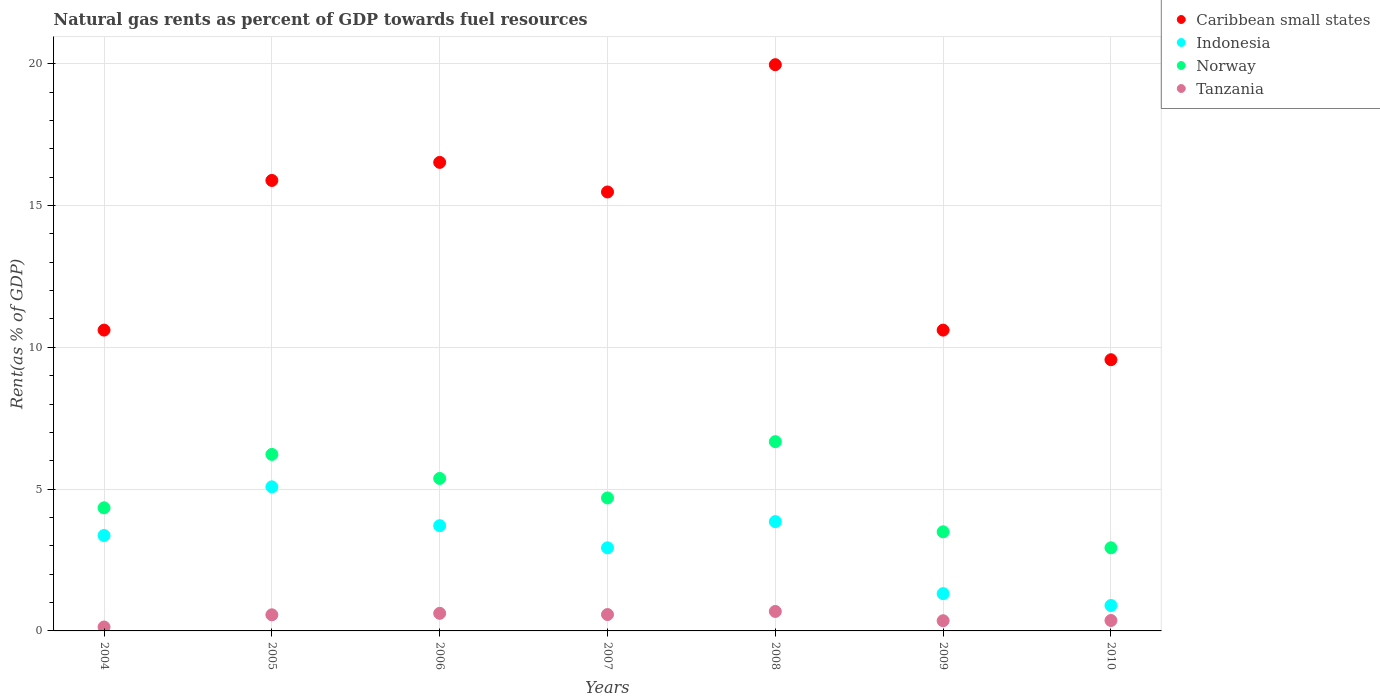How many different coloured dotlines are there?
Ensure brevity in your answer.  4. What is the matural gas rent in Tanzania in 2006?
Provide a short and direct response. 0.62. Across all years, what is the maximum matural gas rent in Caribbean small states?
Provide a succinct answer. 19.97. Across all years, what is the minimum matural gas rent in Caribbean small states?
Your response must be concise. 9.56. What is the total matural gas rent in Norway in the graph?
Make the answer very short. 33.73. What is the difference between the matural gas rent in Indonesia in 2006 and that in 2009?
Your answer should be compact. 2.4. What is the difference between the matural gas rent in Tanzania in 2006 and the matural gas rent in Norway in 2005?
Give a very brief answer. -5.6. What is the average matural gas rent in Indonesia per year?
Offer a very short reply. 3.02. In the year 2008, what is the difference between the matural gas rent in Caribbean small states and matural gas rent in Tanzania?
Ensure brevity in your answer.  19.28. What is the ratio of the matural gas rent in Tanzania in 2006 to that in 2007?
Your response must be concise. 1.07. Is the matural gas rent in Caribbean small states in 2004 less than that in 2006?
Your answer should be very brief. Yes. What is the difference between the highest and the second highest matural gas rent in Indonesia?
Keep it short and to the point. 1.23. What is the difference between the highest and the lowest matural gas rent in Norway?
Your answer should be compact. 3.74. In how many years, is the matural gas rent in Caribbean small states greater than the average matural gas rent in Caribbean small states taken over all years?
Make the answer very short. 4. Is it the case that in every year, the sum of the matural gas rent in Norway and matural gas rent in Caribbean small states  is greater than the sum of matural gas rent in Indonesia and matural gas rent in Tanzania?
Keep it short and to the point. Yes. Is the matural gas rent in Norway strictly less than the matural gas rent in Caribbean small states over the years?
Provide a short and direct response. Yes. How many dotlines are there?
Your answer should be compact. 4. How many years are there in the graph?
Provide a short and direct response. 7. Does the graph contain any zero values?
Offer a terse response. No. Where does the legend appear in the graph?
Make the answer very short. Top right. What is the title of the graph?
Keep it short and to the point. Natural gas rents as percent of GDP towards fuel resources. Does "Vanuatu" appear as one of the legend labels in the graph?
Provide a succinct answer. No. What is the label or title of the X-axis?
Your response must be concise. Years. What is the label or title of the Y-axis?
Your response must be concise. Rent(as % of GDP). What is the Rent(as % of GDP) in Caribbean small states in 2004?
Give a very brief answer. 10.61. What is the Rent(as % of GDP) of Indonesia in 2004?
Provide a short and direct response. 3.36. What is the Rent(as % of GDP) of Norway in 2004?
Give a very brief answer. 4.34. What is the Rent(as % of GDP) in Tanzania in 2004?
Your answer should be very brief. 0.14. What is the Rent(as % of GDP) of Caribbean small states in 2005?
Offer a terse response. 15.89. What is the Rent(as % of GDP) of Indonesia in 2005?
Provide a succinct answer. 5.08. What is the Rent(as % of GDP) of Norway in 2005?
Your answer should be very brief. 6.22. What is the Rent(as % of GDP) in Tanzania in 2005?
Provide a short and direct response. 0.57. What is the Rent(as % of GDP) of Caribbean small states in 2006?
Your response must be concise. 16.52. What is the Rent(as % of GDP) in Indonesia in 2006?
Offer a terse response. 3.71. What is the Rent(as % of GDP) of Norway in 2006?
Your answer should be compact. 5.38. What is the Rent(as % of GDP) of Tanzania in 2006?
Give a very brief answer. 0.62. What is the Rent(as % of GDP) in Caribbean small states in 2007?
Your answer should be very brief. 15.48. What is the Rent(as % of GDP) in Indonesia in 2007?
Your answer should be compact. 2.93. What is the Rent(as % of GDP) of Norway in 2007?
Ensure brevity in your answer.  4.69. What is the Rent(as % of GDP) in Tanzania in 2007?
Keep it short and to the point. 0.58. What is the Rent(as % of GDP) in Caribbean small states in 2008?
Your answer should be compact. 19.97. What is the Rent(as % of GDP) in Indonesia in 2008?
Offer a very short reply. 3.85. What is the Rent(as % of GDP) in Norway in 2008?
Your answer should be compact. 6.67. What is the Rent(as % of GDP) of Tanzania in 2008?
Your response must be concise. 0.69. What is the Rent(as % of GDP) in Caribbean small states in 2009?
Provide a short and direct response. 10.61. What is the Rent(as % of GDP) of Indonesia in 2009?
Your answer should be very brief. 1.32. What is the Rent(as % of GDP) in Norway in 2009?
Your response must be concise. 3.49. What is the Rent(as % of GDP) of Tanzania in 2009?
Make the answer very short. 0.36. What is the Rent(as % of GDP) of Caribbean small states in 2010?
Offer a very short reply. 9.56. What is the Rent(as % of GDP) in Indonesia in 2010?
Your answer should be compact. 0.9. What is the Rent(as % of GDP) in Norway in 2010?
Your response must be concise. 2.93. What is the Rent(as % of GDP) in Tanzania in 2010?
Keep it short and to the point. 0.37. Across all years, what is the maximum Rent(as % of GDP) of Caribbean small states?
Offer a terse response. 19.97. Across all years, what is the maximum Rent(as % of GDP) of Indonesia?
Ensure brevity in your answer.  5.08. Across all years, what is the maximum Rent(as % of GDP) of Norway?
Keep it short and to the point. 6.67. Across all years, what is the maximum Rent(as % of GDP) in Tanzania?
Provide a succinct answer. 0.69. Across all years, what is the minimum Rent(as % of GDP) of Caribbean small states?
Your answer should be very brief. 9.56. Across all years, what is the minimum Rent(as % of GDP) of Indonesia?
Provide a short and direct response. 0.9. Across all years, what is the minimum Rent(as % of GDP) in Norway?
Your answer should be very brief. 2.93. Across all years, what is the minimum Rent(as % of GDP) of Tanzania?
Provide a short and direct response. 0.14. What is the total Rent(as % of GDP) of Caribbean small states in the graph?
Offer a very short reply. 98.63. What is the total Rent(as % of GDP) in Indonesia in the graph?
Your answer should be very brief. 21.15. What is the total Rent(as % of GDP) in Norway in the graph?
Your answer should be compact. 33.73. What is the total Rent(as % of GDP) of Tanzania in the graph?
Your response must be concise. 3.32. What is the difference between the Rent(as % of GDP) in Caribbean small states in 2004 and that in 2005?
Keep it short and to the point. -5.28. What is the difference between the Rent(as % of GDP) in Indonesia in 2004 and that in 2005?
Make the answer very short. -1.72. What is the difference between the Rent(as % of GDP) of Norway in 2004 and that in 2005?
Your answer should be compact. -1.88. What is the difference between the Rent(as % of GDP) of Tanzania in 2004 and that in 2005?
Make the answer very short. -0.43. What is the difference between the Rent(as % of GDP) in Caribbean small states in 2004 and that in 2006?
Your answer should be very brief. -5.91. What is the difference between the Rent(as % of GDP) in Indonesia in 2004 and that in 2006?
Your response must be concise. -0.35. What is the difference between the Rent(as % of GDP) in Norway in 2004 and that in 2006?
Make the answer very short. -1.04. What is the difference between the Rent(as % of GDP) of Tanzania in 2004 and that in 2006?
Ensure brevity in your answer.  -0.48. What is the difference between the Rent(as % of GDP) of Caribbean small states in 2004 and that in 2007?
Give a very brief answer. -4.87. What is the difference between the Rent(as % of GDP) in Indonesia in 2004 and that in 2007?
Your answer should be compact. 0.44. What is the difference between the Rent(as % of GDP) in Norway in 2004 and that in 2007?
Provide a short and direct response. -0.35. What is the difference between the Rent(as % of GDP) of Tanzania in 2004 and that in 2007?
Provide a succinct answer. -0.44. What is the difference between the Rent(as % of GDP) of Caribbean small states in 2004 and that in 2008?
Your answer should be very brief. -9.36. What is the difference between the Rent(as % of GDP) in Indonesia in 2004 and that in 2008?
Your answer should be very brief. -0.49. What is the difference between the Rent(as % of GDP) of Norway in 2004 and that in 2008?
Offer a terse response. -2.33. What is the difference between the Rent(as % of GDP) in Tanzania in 2004 and that in 2008?
Provide a short and direct response. -0.55. What is the difference between the Rent(as % of GDP) of Caribbean small states in 2004 and that in 2009?
Ensure brevity in your answer.  0. What is the difference between the Rent(as % of GDP) in Indonesia in 2004 and that in 2009?
Make the answer very short. 2.05. What is the difference between the Rent(as % of GDP) in Norway in 2004 and that in 2009?
Make the answer very short. 0.85. What is the difference between the Rent(as % of GDP) of Tanzania in 2004 and that in 2009?
Your answer should be very brief. -0.22. What is the difference between the Rent(as % of GDP) of Caribbean small states in 2004 and that in 2010?
Your response must be concise. 1.04. What is the difference between the Rent(as % of GDP) in Indonesia in 2004 and that in 2010?
Give a very brief answer. 2.47. What is the difference between the Rent(as % of GDP) in Norway in 2004 and that in 2010?
Your response must be concise. 1.41. What is the difference between the Rent(as % of GDP) of Tanzania in 2004 and that in 2010?
Your response must be concise. -0.23. What is the difference between the Rent(as % of GDP) in Caribbean small states in 2005 and that in 2006?
Give a very brief answer. -0.64. What is the difference between the Rent(as % of GDP) of Indonesia in 2005 and that in 2006?
Make the answer very short. 1.37. What is the difference between the Rent(as % of GDP) of Norway in 2005 and that in 2006?
Ensure brevity in your answer.  0.85. What is the difference between the Rent(as % of GDP) in Tanzania in 2005 and that in 2006?
Offer a terse response. -0.05. What is the difference between the Rent(as % of GDP) of Caribbean small states in 2005 and that in 2007?
Your response must be concise. 0.41. What is the difference between the Rent(as % of GDP) of Indonesia in 2005 and that in 2007?
Provide a succinct answer. 2.15. What is the difference between the Rent(as % of GDP) in Norway in 2005 and that in 2007?
Offer a very short reply. 1.54. What is the difference between the Rent(as % of GDP) in Tanzania in 2005 and that in 2007?
Offer a very short reply. -0.01. What is the difference between the Rent(as % of GDP) in Caribbean small states in 2005 and that in 2008?
Make the answer very short. -4.08. What is the difference between the Rent(as % of GDP) in Indonesia in 2005 and that in 2008?
Offer a terse response. 1.23. What is the difference between the Rent(as % of GDP) of Norway in 2005 and that in 2008?
Ensure brevity in your answer.  -0.45. What is the difference between the Rent(as % of GDP) in Tanzania in 2005 and that in 2008?
Provide a succinct answer. -0.12. What is the difference between the Rent(as % of GDP) in Caribbean small states in 2005 and that in 2009?
Keep it short and to the point. 5.28. What is the difference between the Rent(as % of GDP) in Indonesia in 2005 and that in 2009?
Your answer should be compact. 3.77. What is the difference between the Rent(as % of GDP) in Norway in 2005 and that in 2009?
Provide a short and direct response. 2.73. What is the difference between the Rent(as % of GDP) in Tanzania in 2005 and that in 2009?
Give a very brief answer. 0.21. What is the difference between the Rent(as % of GDP) of Caribbean small states in 2005 and that in 2010?
Make the answer very short. 6.32. What is the difference between the Rent(as % of GDP) of Indonesia in 2005 and that in 2010?
Your response must be concise. 4.18. What is the difference between the Rent(as % of GDP) of Norway in 2005 and that in 2010?
Your answer should be very brief. 3.29. What is the difference between the Rent(as % of GDP) of Tanzania in 2005 and that in 2010?
Give a very brief answer. 0.2. What is the difference between the Rent(as % of GDP) of Caribbean small states in 2006 and that in 2007?
Your answer should be compact. 1.04. What is the difference between the Rent(as % of GDP) of Indonesia in 2006 and that in 2007?
Your answer should be very brief. 0.78. What is the difference between the Rent(as % of GDP) in Norway in 2006 and that in 2007?
Your answer should be compact. 0.69. What is the difference between the Rent(as % of GDP) of Tanzania in 2006 and that in 2007?
Your answer should be compact. 0.04. What is the difference between the Rent(as % of GDP) in Caribbean small states in 2006 and that in 2008?
Provide a short and direct response. -3.45. What is the difference between the Rent(as % of GDP) in Indonesia in 2006 and that in 2008?
Keep it short and to the point. -0.14. What is the difference between the Rent(as % of GDP) of Norway in 2006 and that in 2008?
Your answer should be very brief. -1.3. What is the difference between the Rent(as % of GDP) in Tanzania in 2006 and that in 2008?
Your answer should be compact. -0.07. What is the difference between the Rent(as % of GDP) of Caribbean small states in 2006 and that in 2009?
Ensure brevity in your answer.  5.91. What is the difference between the Rent(as % of GDP) in Indonesia in 2006 and that in 2009?
Ensure brevity in your answer.  2.4. What is the difference between the Rent(as % of GDP) in Norway in 2006 and that in 2009?
Provide a succinct answer. 1.88. What is the difference between the Rent(as % of GDP) in Tanzania in 2006 and that in 2009?
Provide a succinct answer. 0.26. What is the difference between the Rent(as % of GDP) in Caribbean small states in 2006 and that in 2010?
Keep it short and to the point. 6.96. What is the difference between the Rent(as % of GDP) in Indonesia in 2006 and that in 2010?
Offer a very short reply. 2.81. What is the difference between the Rent(as % of GDP) of Norway in 2006 and that in 2010?
Offer a terse response. 2.45. What is the difference between the Rent(as % of GDP) of Tanzania in 2006 and that in 2010?
Provide a succinct answer. 0.25. What is the difference between the Rent(as % of GDP) in Caribbean small states in 2007 and that in 2008?
Your response must be concise. -4.49. What is the difference between the Rent(as % of GDP) of Indonesia in 2007 and that in 2008?
Your answer should be very brief. -0.93. What is the difference between the Rent(as % of GDP) of Norway in 2007 and that in 2008?
Offer a terse response. -1.99. What is the difference between the Rent(as % of GDP) of Tanzania in 2007 and that in 2008?
Offer a very short reply. -0.11. What is the difference between the Rent(as % of GDP) in Caribbean small states in 2007 and that in 2009?
Provide a succinct answer. 4.87. What is the difference between the Rent(as % of GDP) in Indonesia in 2007 and that in 2009?
Offer a very short reply. 1.61. What is the difference between the Rent(as % of GDP) in Norway in 2007 and that in 2009?
Provide a short and direct response. 1.19. What is the difference between the Rent(as % of GDP) in Tanzania in 2007 and that in 2009?
Make the answer very short. 0.22. What is the difference between the Rent(as % of GDP) in Caribbean small states in 2007 and that in 2010?
Your answer should be compact. 5.92. What is the difference between the Rent(as % of GDP) of Indonesia in 2007 and that in 2010?
Provide a succinct answer. 2.03. What is the difference between the Rent(as % of GDP) in Norway in 2007 and that in 2010?
Your response must be concise. 1.76. What is the difference between the Rent(as % of GDP) in Tanzania in 2007 and that in 2010?
Give a very brief answer. 0.21. What is the difference between the Rent(as % of GDP) in Caribbean small states in 2008 and that in 2009?
Offer a very short reply. 9.36. What is the difference between the Rent(as % of GDP) in Indonesia in 2008 and that in 2009?
Offer a very short reply. 2.54. What is the difference between the Rent(as % of GDP) of Norway in 2008 and that in 2009?
Your response must be concise. 3.18. What is the difference between the Rent(as % of GDP) of Tanzania in 2008 and that in 2009?
Make the answer very short. 0.33. What is the difference between the Rent(as % of GDP) in Caribbean small states in 2008 and that in 2010?
Provide a short and direct response. 10.4. What is the difference between the Rent(as % of GDP) in Indonesia in 2008 and that in 2010?
Offer a terse response. 2.96. What is the difference between the Rent(as % of GDP) of Norway in 2008 and that in 2010?
Your response must be concise. 3.74. What is the difference between the Rent(as % of GDP) in Tanzania in 2008 and that in 2010?
Ensure brevity in your answer.  0.32. What is the difference between the Rent(as % of GDP) of Caribbean small states in 2009 and that in 2010?
Offer a terse response. 1.04. What is the difference between the Rent(as % of GDP) in Indonesia in 2009 and that in 2010?
Your answer should be very brief. 0.42. What is the difference between the Rent(as % of GDP) of Norway in 2009 and that in 2010?
Ensure brevity in your answer.  0.56. What is the difference between the Rent(as % of GDP) in Tanzania in 2009 and that in 2010?
Your answer should be very brief. -0.01. What is the difference between the Rent(as % of GDP) of Caribbean small states in 2004 and the Rent(as % of GDP) of Indonesia in 2005?
Your response must be concise. 5.53. What is the difference between the Rent(as % of GDP) of Caribbean small states in 2004 and the Rent(as % of GDP) of Norway in 2005?
Your response must be concise. 4.38. What is the difference between the Rent(as % of GDP) of Caribbean small states in 2004 and the Rent(as % of GDP) of Tanzania in 2005?
Your answer should be very brief. 10.04. What is the difference between the Rent(as % of GDP) in Indonesia in 2004 and the Rent(as % of GDP) in Norway in 2005?
Offer a very short reply. -2.86. What is the difference between the Rent(as % of GDP) of Indonesia in 2004 and the Rent(as % of GDP) of Tanzania in 2005?
Provide a succinct answer. 2.8. What is the difference between the Rent(as % of GDP) in Norway in 2004 and the Rent(as % of GDP) in Tanzania in 2005?
Provide a succinct answer. 3.77. What is the difference between the Rent(as % of GDP) of Caribbean small states in 2004 and the Rent(as % of GDP) of Indonesia in 2006?
Keep it short and to the point. 6.9. What is the difference between the Rent(as % of GDP) of Caribbean small states in 2004 and the Rent(as % of GDP) of Norway in 2006?
Give a very brief answer. 5.23. What is the difference between the Rent(as % of GDP) in Caribbean small states in 2004 and the Rent(as % of GDP) in Tanzania in 2006?
Ensure brevity in your answer.  9.99. What is the difference between the Rent(as % of GDP) of Indonesia in 2004 and the Rent(as % of GDP) of Norway in 2006?
Keep it short and to the point. -2.01. What is the difference between the Rent(as % of GDP) in Indonesia in 2004 and the Rent(as % of GDP) in Tanzania in 2006?
Your answer should be very brief. 2.74. What is the difference between the Rent(as % of GDP) of Norway in 2004 and the Rent(as % of GDP) of Tanzania in 2006?
Your answer should be compact. 3.72. What is the difference between the Rent(as % of GDP) of Caribbean small states in 2004 and the Rent(as % of GDP) of Indonesia in 2007?
Give a very brief answer. 7.68. What is the difference between the Rent(as % of GDP) of Caribbean small states in 2004 and the Rent(as % of GDP) of Norway in 2007?
Offer a terse response. 5.92. What is the difference between the Rent(as % of GDP) in Caribbean small states in 2004 and the Rent(as % of GDP) in Tanzania in 2007?
Make the answer very short. 10.03. What is the difference between the Rent(as % of GDP) of Indonesia in 2004 and the Rent(as % of GDP) of Norway in 2007?
Your answer should be very brief. -1.32. What is the difference between the Rent(as % of GDP) in Indonesia in 2004 and the Rent(as % of GDP) in Tanzania in 2007?
Offer a very short reply. 2.79. What is the difference between the Rent(as % of GDP) in Norway in 2004 and the Rent(as % of GDP) in Tanzania in 2007?
Ensure brevity in your answer.  3.76. What is the difference between the Rent(as % of GDP) of Caribbean small states in 2004 and the Rent(as % of GDP) of Indonesia in 2008?
Keep it short and to the point. 6.75. What is the difference between the Rent(as % of GDP) of Caribbean small states in 2004 and the Rent(as % of GDP) of Norway in 2008?
Your answer should be very brief. 3.93. What is the difference between the Rent(as % of GDP) of Caribbean small states in 2004 and the Rent(as % of GDP) of Tanzania in 2008?
Keep it short and to the point. 9.92. What is the difference between the Rent(as % of GDP) in Indonesia in 2004 and the Rent(as % of GDP) in Norway in 2008?
Provide a succinct answer. -3.31. What is the difference between the Rent(as % of GDP) of Indonesia in 2004 and the Rent(as % of GDP) of Tanzania in 2008?
Make the answer very short. 2.68. What is the difference between the Rent(as % of GDP) of Norway in 2004 and the Rent(as % of GDP) of Tanzania in 2008?
Offer a very short reply. 3.65. What is the difference between the Rent(as % of GDP) of Caribbean small states in 2004 and the Rent(as % of GDP) of Indonesia in 2009?
Offer a terse response. 9.29. What is the difference between the Rent(as % of GDP) of Caribbean small states in 2004 and the Rent(as % of GDP) of Norway in 2009?
Your answer should be compact. 7.11. What is the difference between the Rent(as % of GDP) in Caribbean small states in 2004 and the Rent(as % of GDP) in Tanzania in 2009?
Ensure brevity in your answer.  10.25. What is the difference between the Rent(as % of GDP) in Indonesia in 2004 and the Rent(as % of GDP) in Norway in 2009?
Your answer should be compact. -0.13. What is the difference between the Rent(as % of GDP) in Indonesia in 2004 and the Rent(as % of GDP) in Tanzania in 2009?
Offer a terse response. 3.01. What is the difference between the Rent(as % of GDP) of Norway in 2004 and the Rent(as % of GDP) of Tanzania in 2009?
Ensure brevity in your answer.  3.98. What is the difference between the Rent(as % of GDP) in Caribbean small states in 2004 and the Rent(as % of GDP) in Indonesia in 2010?
Your answer should be very brief. 9.71. What is the difference between the Rent(as % of GDP) in Caribbean small states in 2004 and the Rent(as % of GDP) in Norway in 2010?
Offer a very short reply. 7.68. What is the difference between the Rent(as % of GDP) in Caribbean small states in 2004 and the Rent(as % of GDP) in Tanzania in 2010?
Ensure brevity in your answer.  10.24. What is the difference between the Rent(as % of GDP) of Indonesia in 2004 and the Rent(as % of GDP) of Norway in 2010?
Ensure brevity in your answer.  0.43. What is the difference between the Rent(as % of GDP) in Indonesia in 2004 and the Rent(as % of GDP) in Tanzania in 2010?
Your answer should be very brief. 3. What is the difference between the Rent(as % of GDP) in Norway in 2004 and the Rent(as % of GDP) in Tanzania in 2010?
Provide a succinct answer. 3.97. What is the difference between the Rent(as % of GDP) of Caribbean small states in 2005 and the Rent(as % of GDP) of Indonesia in 2006?
Provide a short and direct response. 12.17. What is the difference between the Rent(as % of GDP) in Caribbean small states in 2005 and the Rent(as % of GDP) in Norway in 2006?
Your answer should be compact. 10.51. What is the difference between the Rent(as % of GDP) of Caribbean small states in 2005 and the Rent(as % of GDP) of Tanzania in 2006?
Ensure brevity in your answer.  15.27. What is the difference between the Rent(as % of GDP) of Indonesia in 2005 and the Rent(as % of GDP) of Norway in 2006?
Keep it short and to the point. -0.3. What is the difference between the Rent(as % of GDP) of Indonesia in 2005 and the Rent(as % of GDP) of Tanzania in 2006?
Provide a short and direct response. 4.46. What is the difference between the Rent(as % of GDP) of Norway in 2005 and the Rent(as % of GDP) of Tanzania in 2006?
Offer a very short reply. 5.6. What is the difference between the Rent(as % of GDP) in Caribbean small states in 2005 and the Rent(as % of GDP) in Indonesia in 2007?
Keep it short and to the point. 12.96. What is the difference between the Rent(as % of GDP) in Caribbean small states in 2005 and the Rent(as % of GDP) in Norway in 2007?
Keep it short and to the point. 11.2. What is the difference between the Rent(as % of GDP) in Caribbean small states in 2005 and the Rent(as % of GDP) in Tanzania in 2007?
Offer a very short reply. 15.31. What is the difference between the Rent(as % of GDP) of Indonesia in 2005 and the Rent(as % of GDP) of Norway in 2007?
Your answer should be very brief. 0.39. What is the difference between the Rent(as % of GDP) in Indonesia in 2005 and the Rent(as % of GDP) in Tanzania in 2007?
Make the answer very short. 4.5. What is the difference between the Rent(as % of GDP) in Norway in 2005 and the Rent(as % of GDP) in Tanzania in 2007?
Offer a very short reply. 5.65. What is the difference between the Rent(as % of GDP) of Caribbean small states in 2005 and the Rent(as % of GDP) of Indonesia in 2008?
Your answer should be compact. 12.03. What is the difference between the Rent(as % of GDP) of Caribbean small states in 2005 and the Rent(as % of GDP) of Norway in 2008?
Provide a succinct answer. 9.21. What is the difference between the Rent(as % of GDP) of Caribbean small states in 2005 and the Rent(as % of GDP) of Tanzania in 2008?
Keep it short and to the point. 15.2. What is the difference between the Rent(as % of GDP) in Indonesia in 2005 and the Rent(as % of GDP) in Norway in 2008?
Make the answer very short. -1.59. What is the difference between the Rent(as % of GDP) of Indonesia in 2005 and the Rent(as % of GDP) of Tanzania in 2008?
Keep it short and to the point. 4.39. What is the difference between the Rent(as % of GDP) in Norway in 2005 and the Rent(as % of GDP) in Tanzania in 2008?
Provide a succinct answer. 5.54. What is the difference between the Rent(as % of GDP) in Caribbean small states in 2005 and the Rent(as % of GDP) in Indonesia in 2009?
Offer a very short reply. 14.57. What is the difference between the Rent(as % of GDP) in Caribbean small states in 2005 and the Rent(as % of GDP) in Norway in 2009?
Keep it short and to the point. 12.39. What is the difference between the Rent(as % of GDP) of Caribbean small states in 2005 and the Rent(as % of GDP) of Tanzania in 2009?
Provide a short and direct response. 15.53. What is the difference between the Rent(as % of GDP) in Indonesia in 2005 and the Rent(as % of GDP) in Norway in 2009?
Give a very brief answer. 1.59. What is the difference between the Rent(as % of GDP) of Indonesia in 2005 and the Rent(as % of GDP) of Tanzania in 2009?
Ensure brevity in your answer.  4.72. What is the difference between the Rent(as % of GDP) of Norway in 2005 and the Rent(as % of GDP) of Tanzania in 2009?
Offer a very short reply. 5.86. What is the difference between the Rent(as % of GDP) of Caribbean small states in 2005 and the Rent(as % of GDP) of Indonesia in 2010?
Provide a succinct answer. 14.99. What is the difference between the Rent(as % of GDP) in Caribbean small states in 2005 and the Rent(as % of GDP) in Norway in 2010?
Give a very brief answer. 12.95. What is the difference between the Rent(as % of GDP) of Caribbean small states in 2005 and the Rent(as % of GDP) of Tanzania in 2010?
Your answer should be compact. 15.52. What is the difference between the Rent(as % of GDP) of Indonesia in 2005 and the Rent(as % of GDP) of Norway in 2010?
Your answer should be very brief. 2.15. What is the difference between the Rent(as % of GDP) of Indonesia in 2005 and the Rent(as % of GDP) of Tanzania in 2010?
Provide a short and direct response. 4.71. What is the difference between the Rent(as % of GDP) in Norway in 2005 and the Rent(as % of GDP) in Tanzania in 2010?
Provide a short and direct response. 5.86. What is the difference between the Rent(as % of GDP) of Caribbean small states in 2006 and the Rent(as % of GDP) of Indonesia in 2007?
Offer a very short reply. 13.59. What is the difference between the Rent(as % of GDP) of Caribbean small states in 2006 and the Rent(as % of GDP) of Norway in 2007?
Keep it short and to the point. 11.83. What is the difference between the Rent(as % of GDP) of Caribbean small states in 2006 and the Rent(as % of GDP) of Tanzania in 2007?
Provide a short and direct response. 15.94. What is the difference between the Rent(as % of GDP) in Indonesia in 2006 and the Rent(as % of GDP) in Norway in 2007?
Provide a short and direct response. -0.98. What is the difference between the Rent(as % of GDP) in Indonesia in 2006 and the Rent(as % of GDP) in Tanzania in 2007?
Your answer should be very brief. 3.13. What is the difference between the Rent(as % of GDP) in Norway in 2006 and the Rent(as % of GDP) in Tanzania in 2007?
Make the answer very short. 4.8. What is the difference between the Rent(as % of GDP) in Caribbean small states in 2006 and the Rent(as % of GDP) in Indonesia in 2008?
Offer a terse response. 12.67. What is the difference between the Rent(as % of GDP) of Caribbean small states in 2006 and the Rent(as % of GDP) of Norway in 2008?
Give a very brief answer. 9.85. What is the difference between the Rent(as % of GDP) in Caribbean small states in 2006 and the Rent(as % of GDP) in Tanzania in 2008?
Give a very brief answer. 15.83. What is the difference between the Rent(as % of GDP) of Indonesia in 2006 and the Rent(as % of GDP) of Norway in 2008?
Your response must be concise. -2.96. What is the difference between the Rent(as % of GDP) of Indonesia in 2006 and the Rent(as % of GDP) of Tanzania in 2008?
Your answer should be very brief. 3.02. What is the difference between the Rent(as % of GDP) in Norway in 2006 and the Rent(as % of GDP) in Tanzania in 2008?
Make the answer very short. 4.69. What is the difference between the Rent(as % of GDP) in Caribbean small states in 2006 and the Rent(as % of GDP) in Indonesia in 2009?
Offer a terse response. 15.21. What is the difference between the Rent(as % of GDP) of Caribbean small states in 2006 and the Rent(as % of GDP) of Norway in 2009?
Your response must be concise. 13.03. What is the difference between the Rent(as % of GDP) of Caribbean small states in 2006 and the Rent(as % of GDP) of Tanzania in 2009?
Keep it short and to the point. 16.16. What is the difference between the Rent(as % of GDP) in Indonesia in 2006 and the Rent(as % of GDP) in Norway in 2009?
Give a very brief answer. 0.22. What is the difference between the Rent(as % of GDP) in Indonesia in 2006 and the Rent(as % of GDP) in Tanzania in 2009?
Your answer should be very brief. 3.35. What is the difference between the Rent(as % of GDP) in Norway in 2006 and the Rent(as % of GDP) in Tanzania in 2009?
Your answer should be very brief. 5.02. What is the difference between the Rent(as % of GDP) of Caribbean small states in 2006 and the Rent(as % of GDP) of Indonesia in 2010?
Ensure brevity in your answer.  15.62. What is the difference between the Rent(as % of GDP) in Caribbean small states in 2006 and the Rent(as % of GDP) in Norway in 2010?
Your response must be concise. 13.59. What is the difference between the Rent(as % of GDP) in Caribbean small states in 2006 and the Rent(as % of GDP) in Tanzania in 2010?
Ensure brevity in your answer.  16.15. What is the difference between the Rent(as % of GDP) of Indonesia in 2006 and the Rent(as % of GDP) of Norway in 2010?
Provide a short and direct response. 0.78. What is the difference between the Rent(as % of GDP) in Indonesia in 2006 and the Rent(as % of GDP) in Tanzania in 2010?
Provide a short and direct response. 3.34. What is the difference between the Rent(as % of GDP) in Norway in 2006 and the Rent(as % of GDP) in Tanzania in 2010?
Make the answer very short. 5.01. What is the difference between the Rent(as % of GDP) in Caribbean small states in 2007 and the Rent(as % of GDP) in Indonesia in 2008?
Ensure brevity in your answer.  11.62. What is the difference between the Rent(as % of GDP) of Caribbean small states in 2007 and the Rent(as % of GDP) of Norway in 2008?
Keep it short and to the point. 8.8. What is the difference between the Rent(as % of GDP) of Caribbean small states in 2007 and the Rent(as % of GDP) of Tanzania in 2008?
Provide a succinct answer. 14.79. What is the difference between the Rent(as % of GDP) of Indonesia in 2007 and the Rent(as % of GDP) of Norway in 2008?
Keep it short and to the point. -3.75. What is the difference between the Rent(as % of GDP) of Indonesia in 2007 and the Rent(as % of GDP) of Tanzania in 2008?
Your answer should be very brief. 2.24. What is the difference between the Rent(as % of GDP) in Norway in 2007 and the Rent(as % of GDP) in Tanzania in 2008?
Provide a short and direct response. 4. What is the difference between the Rent(as % of GDP) of Caribbean small states in 2007 and the Rent(as % of GDP) of Indonesia in 2009?
Provide a succinct answer. 14.16. What is the difference between the Rent(as % of GDP) in Caribbean small states in 2007 and the Rent(as % of GDP) in Norway in 2009?
Your answer should be very brief. 11.98. What is the difference between the Rent(as % of GDP) of Caribbean small states in 2007 and the Rent(as % of GDP) of Tanzania in 2009?
Make the answer very short. 15.12. What is the difference between the Rent(as % of GDP) of Indonesia in 2007 and the Rent(as % of GDP) of Norway in 2009?
Give a very brief answer. -0.57. What is the difference between the Rent(as % of GDP) in Indonesia in 2007 and the Rent(as % of GDP) in Tanzania in 2009?
Provide a succinct answer. 2.57. What is the difference between the Rent(as % of GDP) in Norway in 2007 and the Rent(as % of GDP) in Tanzania in 2009?
Your response must be concise. 4.33. What is the difference between the Rent(as % of GDP) of Caribbean small states in 2007 and the Rent(as % of GDP) of Indonesia in 2010?
Your response must be concise. 14.58. What is the difference between the Rent(as % of GDP) in Caribbean small states in 2007 and the Rent(as % of GDP) in Norway in 2010?
Make the answer very short. 12.55. What is the difference between the Rent(as % of GDP) of Caribbean small states in 2007 and the Rent(as % of GDP) of Tanzania in 2010?
Give a very brief answer. 15.11. What is the difference between the Rent(as % of GDP) in Indonesia in 2007 and the Rent(as % of GDP) in Norway in 2010?
Make the answer very short. -0. What is the difference between the Rent(as % of GDP) of Indonesia in 2007 and the Rent(as % of GDP) of Tanzania in 2010?
Ensure brevity in your answer.  2.56. What is the difference between the Rent(as % of GDP) in Norway in 2007 and the Rent(as % of GDP) in Tanzania in 2010?
Keep it short and to the point. 4.32. What is the difference between the Rent(as % of GDP) in Caribbean small states in 2008 and the Rent(as % of GDP) in Indonesia in 2009?
Ensure brevity in your answer.  18.65. What is the difference between the Rent(as % of GDP) in Caribbean small states in 2008 and the Rent(as % of GDP) in Norway in 2009?
Keep it short and to the point. 16.47. What is the difference between the Rent(as % of GDP) of Caribbean small states in 2008 and the Rent(as % of GDP) of Tanzania in 2009?
Give a very brief answer. 19.61. What is the difference between the Rent(as % of GDP) of Indonesia in 2008 and the Rent(as % of GDP) of Norway in 2009?
Offer a very short reply. 0.36. What is the difference between the Rent(as % of GDP) in Indonesia in 2008 and the Rent(as % of GDP) in Tanzania in 2009?
Your response must be concise. 3.5. What is the difference between the Rent(as % of GDP) in Norway in 2008 and the Rent(as % of GDP) in Tanzania in 2009?
Provide a succinct answer. 6.32. What is the difference between the Rent(as % of GDP) in Caribbean small states in 2008 and the Rent(as % of GDP) in Indonesia in 2010?
Your answer should be very brief. 19.07. What is the difference between the Rent(as % of GDP) of Caribbean small states in 2008 and the Rent(as % of GDP) of Norway in 2010?
Make the answer very short. 17.04. What is the difference between the Rent(as % of GDP) in Caribbean small states in 2008 and the Rent(as % of GDP) in Tanzania in 2010?
Offer a very short reply. 19.6. What is the difference between the Rent(as % of GDP) in Indonesia in 2008 and the Rent(as % of GDP) in Norway in 2010?
Your response must be concise. 0.92. What is the difference between the Rent(as % of GDP) of Indonesia in 2008 and the Rent(as % of GDP) of Tanzania in 2010?
Provide a short and direct response. 3.49. What is the difference between the Rent(as % of GDP) in Norway in 2008 and the Rent(as % of GDP) in Tanzania in 2010?
Ensure brevity in your answer.  6.31. What is the difference between the Rent(as % of GDP) of Caribbean small states in 2009 and the Rent(as % of GDP) of Indonesia in 2010?
Provide a short and direct response. 9.71. What is the difference between the Rent(as % of GDP) in Caribbean small states in 2009 and the Rent(as % of GDP) in Norway in 2010?
Provide a short and direct response. 7.68. What is the difference between the Rent(as % of GDP) in Caribbean small states in 2009 and the Rent(as % of GDP) in Tanzania in 2010?
Ensure brevity in your answer.  10.24. What is the difference between the Rent(as % of GDP) in Indonesia in 2009 and the Rent(as % of GDP) in Norway in 2010?
Your answer should be compact. -1.62. What is the difference between the Rent(as % of GDP) of Indonesia in 2009 and the Rent(as % of GDP) of Tanzania in 2010?
Provide a short and direct response. 0.95. What is the difference between the Rent(as % of GDP) in Norway in 2009 and the Rent(as % of GDP) in Tanzania in 2010?
Offer a terse response. 3.13. What is the average Rent(as % of GDP) of Caribbean small states per year?
Provide a short and direct response. 14.09. What is the average Rent(as % of GDP) in Indonesia per year?
Offer a very short reply. 3.02. What is the average Rent(as % of GDP) of Norway per year?
Provide a succinct answer. 4.82. What is the average Rent(as % of GDP) of Tanzania per year?
Give a very brief answer. 0.47. In the year 2004, what is the difference between the Rent(as % of GDP) of Caribbean small states and Rent(as % of GDP) of Indonesia?
Keep it short and to the point. 7.24. In the year 2004, what is the difference between the Rent(as % of GDP) in Caribbean small states and Rent(as % of GDP) in Norway?
Your answer should be compact. 6.27. In the year 2004, what is the difference between the Rent(as % of GDP) of Caribbean small states and Rent(as % of GDP) of Tanzania?
Ensure brevity in your answer.  10.47. In the year 2004, what is the difference between the Rent(as % of GDP) in Indonesia and Rent(as % of GDP) in Norway?
Offer a very short reply. -0.98. In the year 2004, what is the difference between the Rent(as % of GDP) in Indonesia and Rent(as % of GDP) in Tanzania?
Give a very brief answer. 3.23. In the year 2004, what is the difference between the Rent(as % of GDP) in Norway and Rent(as % of GDP) in Tanzania?
Make the answer very short. 4.2. In the year 2005, what is the difference between the Rent(as % of GDP) in Caribbean small states and Rent(as % of GDP) in Indonesia?
Give a very brief answer. 10.8. In the year 2005, what is the difference between the Rent(as % of GDP) in Caribbean small states and Rent(as % of GDP) in Norway?
Your answer should be very brief. 9.66. In the year 2005, what is the difference between the Rent(as % of GDP) of Caribbean small states and Rent(as % of GDP) of Tanzania?
Keep it short and to the point. 15.32. In the year 2005, what is the difference between the Rent(as % of GDP) in Indonesia and Rent(as % of GDP) in Norway?
Give a very brief answer. -1.14. In the year 2005, what is the difference between the Rent(as % of GDP) of Indonesia and Rent(as % of GDP) of Tanzania?
Your response must be concise. 4.51. In the year 2005, what is the difference between the Rent(as % of GDP) in Norway and Rent(as % of GDP) in Tanzania?
Provide a succinct answer. 5.66. In the year 2006, what is the difference between the Rent(as % of GDP) of Caribbean small states and Rent(as % of GDP) of Indonesia?
Provide a short and direct response. 12.81. In the year 2006, what is the difference between the Rent(as % of GDP) in Caribbean small states and Rent(as % of GDP) in Norway?
Make the answer very short. 11.14. In the year 2006, what is the difference between the Rent(as % of GDP) of Caribbean small states and Rent(as % of GDP) of Tanzania?
Ensure brevity in your answer.  15.9. In the year 2006, what is the difference between the Rent(as % of GDP) of Indonesia and Rent(as % of GDP) of Norway?
Ensure brevity in your answer.  -1.67. In the year 2006, what is the difference between the Rent(as % of GDP) in Indonesia and Rent(as % of GDP) in Tanzania?
Your response must be concise. 3.09. In the year 2006, what is the difference between the Rent(as % of GDP) in Norway and Rent(as % of GDP) in Tanzania?
Offer a terse response. 4.76. In the year 2007, what is the difference between the Rent(as % of GDP) in Caribbean small states and Rent(as % of GDP) in Indonesia?
Offer a very short reply. 12.55. In the year 2007, what is the difference between the Rent(as % of GDP) of Caribbean small states and Rent(as % of GDP) of Norway?
Offer a very short reply. 10.79. In the year 2007, what is the difference between the Rent(as % of GDP) in Caribbean small states and Rent(as % of GDP) in Tanzania?
Your answer should be very brief. 14.9. In the year 2007, what is the difference between the Rent(as % of GDP) of Indonesia and Rent(as % of GDP) of Norway?
Your answer should be compact. -1.76. In the year 2007, what is the difference between the Rent(as % of GDP) of Indonesia and Rent(as % of GDP) of Tanzania?
Offer a very short reply. 2.35. In the year 2007, what is the difference between the Rent(as % of GDP) of Norway and Rent(as % of GDP) of Tanzania?
Your response must be concise. 4.11. In the year 2008, what is the difference between the Rent(as % of GDP) in Caribbean small states and Rent(as % of GDP) in Indonesia?
Ensure brevity in your answer.  16.11. In the year 2008, what is the difference between the Rent(as % of GDP) in Caribbean small states and Rent(as % of GDP) in Norway?
Make the answer very short. 13.29. In the year 2008, what is the difference between the Rent(as % of GDP) in Caribbean small states and Rent(as % of GDP) in Tanzania?
Your response must be concise. 19.28. In the year 2008, what is the difference between the Rent(as % of GDP) in Indonesia and Rent(as % of GDP) in Norway?
Provide a short and direct response. -2.82. In the year 2008, what is the difference between the Rent(as % of GDP) of Indonesia and Rent(as % of GDP) of Tanzania?
Provide a succinct answer. 3.17. In the year 2008, what is the difference between the Rent(as % of GDP) in Norway and Rent(as % of GDP) in Tanzania?
Ensure brevity in your answer.  5.99. In the year 2009, what is the difference between the Rent(as % of GDP) of Caribbean small states and Rent(as % of GDP) of Indonesia?
Your answer should be compact. 9.29. In the year 2009, what is the difference between the Rent(as % of GDP) in Caribbean small states and Rent(as % of GDP) in Norway?
Your response must be concise. 7.11. In the year 2009, what is the difference between the Rent(as % of GDP) in Caribbean small states and Rent(as % of GDP) in Tanzania?
Give a very brief answer. 10.25. In the year 2009, what is the difference between the Rent(as % of GDP) in Indonesia and Rent(as % of GDP) in Norway?
Offer a very short reply. -2.18. In the year 2009, what is the difference between the Rent(as % of GDP) in Indonesia and Rent(as % of GDP) in Tanzania?
Your response must be concise. 0.96. In the year 2009, what is the difference between the Rent(as % of GDP) in Norway and Rent(as % of GDP) in Tanzania?
Make the answer very short. 3.14. In the year 2010, what is the difference between the Rent(as % of GDP) of Caribbean small states and Rent(as % of GDP) of Indonesia?
Your answer should be very brief. 8.67. In the year 2010, what is the difference between the Rent(as % of GDP) in Caribbean small states and Rent(as % of GDP) in Norway?
Make the answer very short. 6.63. In the year 2010, what is the difference between the Rent(as % of GDP) in Caribbean small states and Rent(as % of GDP) in Tanzania?
Keep it short and to the point. 9.2. In the year 2010, what is the difference between the Rent(as % of GDP) of Indonesia and Rent(as % of GDP) of Norway?
Keep it short and to the point. -2.03. In the year 2010, what is the difference between the Rent(as % of GDP) of Indonesia and Rent(as % of GDP) of Tanzania?
Your answer should be very brief. 0.53. In the year 2010, what is the difference between the Rent(as % of GDP) in Norway and Rent(as % of GDP) in Tanzania?
Provide a short and direct response. 2.56. What is the ratio of the Rent(as % of GDP) in Caribbean small states in 2004 to that in 2005?
Your answer should be compact. 0.67. What is the ratio of the Rent(as % of GDP) in Indonesia in 2004 to that in 2005?
Give a very brief answer. 0.66. What is the ratio of the Rent(as % of GDP) in Norway in 2004 to that in 2005?
Ensure brevity in your answer.  0.7. What is the ratio of the Rent(as % of GDP) of Tanzania in 2004 to that in 2005?
Keep it short and to the point. 0.24. What is the ratio of the Rent(as % of GDP) of Caribbean small states in 2004 to that in 2006?
Give a very brief answer. 0.64. What is the ratio of the Rent(as % of GDP) in Indonesia in 2004 to that in 2006?
Keep it short and to the point. 0.91. What is the ratio of the Rent(as % of GDP) of Norway in 2004 to that in 2006?
Provide a succinct answer. 0.81. What is the ratio of the Rent(as % of GDP) of Tanzania in 2004 to that in 2006?
Offer a very short reply. 0.22. What is the ratio of the Rent(as % of GDP) in Caribbean small states in 2004 to that in 2007?
Provide a succinct answer. 0.69. What is the ratio of the Rent(as % of GDP) of Indonesia in 2004 to that in 2007?
Your answer should be compact. 1.15. What is the ratio of the Rent(as % of GDP) in Norway in 2004 to that in 2007?
Your answer should be very brief. 0.93. What is the ratio of the Rent(as % of GDP) in Tanzania in 2004 to that in 2007?
Your answer should be very brief. 0.24. What is the ratio of the Rent(as % of GDP) in Caribbean small states in 2004 to that in 2008?
Offer a terse response. 0.53. What is the ratio of the Rent(as % of GDP) of Indonesia in 2004 to that in 2008?
Make the answer very short. 0.87. What is the ratio of the Rent(as % of GDP) of Norway in 2004 to that in 2008?
Make the answer very short. 0.65. What is the ratio of the Rent(as % of GDP) in Tanzania in 2004 to that in 2008?
Give a very brief answer. 0.2. What is the ratio of the Rent(as % of GDP) in Indonesia in 2004 to that in 2009?
Your answer should be compact. 2.56. What is the ratio of the Rent(as % of GDP) of Norway in 2004 to that in 2009?
Your answer should be very brief. 1.24. What is the ratio of the Rent(as % of GDP) in Tanzania in 2004 to that in 2009?
Provide a short and direct response. 0.39. What is the ratio of the Rent(as % of GDP) of Caribbean small states in 2004 to that in 2010?
Give a very brief answer. 1.11. What is the ratio of the Rent(as % of GDP) in Indonesia in 2004 to that in 2010?
Your answer should be very brief. 3.75. What is the ratio of the Rent(as % of GDP) of Norway in 2004 to that in 2010?
Keep it short and to the point. 1.48. What is the ratio of the Rent(as % of GDP) in Tanzania in 2004 to that in 2010?
Ensure brevity in your answer.  0.38. What is the ratio of the Rent(as % of GDP) in Caribbean small states in 2005 to that in 2006?
Offer a very short reply. 0.96. What is the ratio of the Rent(as % of GDP) in Indonesia in 2005 to that in 2006?
Your answer should be very brief. 1.37. What is the ratio of the Rent(as % of GDP) in Norway in 2005 to that in 2006?
Give a very brief answer. 1.16. What is the ratio of the Rent(as % of GDP) of Tanzania in 2005 to that in 2006?
Your answer should be very brief. 0.92. What is the ratio of the Rent(as % of GDP) in Caribbean small states in 2005 to that in 2007?
Provide a short and direct response. 1.03. What is the ratio of the Rent(as % of GDP) in Indonesia in 2005 to that in 2007?
Offer a very short reply. 1.73. What is the ratio of the Rent(as % of GDP) of Norway in 2005 to that in 2007?
Your response must be concise. 1.33. What is the ratio of the Rent(as % of GDP) in Tanzania in 2005 to that in 2007?
Provide a succinct answer. 0.98. What is the ratio of the Rent(as % of GDP) of Caribbean small states in 2005 to that in 2008?
Offer a very short reply. 0.8. What is the ratio of the Rent(as % of GDP) in Indonesia in 2005 to that in 2008?
Offer a terse response. 1.32. What is the ratio of the Rent(as % of GDP) of Norway in 2005 to that in 2008?
Provide a short and direct response. 0.93. What is the ratio of the Rent(as % of GDP) in Tanzania in 2005 to that in 2008?
Your answer should be very brief. 0.83. What is the ratio of the Rent(as % of GDP) of Caribbean small states in 2005 to that in 2009?
Provide a short and direct response. 1.5. What is the ratio of the Rent(as % of GDP) in Indonesia in 2005 to that in 2009?
Provide a succinct answer. 3.86. What is the ratio of the Rent(as % of GDP) of Norway in 2005 to that in 2009?
Give a very brief answer. 1.78. What is the ratio of the Rent(as % of GDP) in Tanzania in 2005 to that in 2009?
Make the answer very short. 1.58. What is the ratio of the Rent(as % of GDP) in Caribbean small states in 2005 to that in 2010?
Offer a very short reply. 1.66. What is the ratio of the Rent(as % of GDP) of Indonesia in 2005 to that in 2010?
Offer a terse response. 5.67. What is the ratio of the Rent(as % of GDP) in Norway in 2005 to that in 2010?
Offer a terse response. 2.12. What is the ratio of the Rent(as % of GDP) of Tanzania in 2005 to that in 2010?
Ensure brevity in your answer.  1.55. What is the ratio of the Rent(as % of GDP) in Caribbean small states in 2006 to that in 2007?
Provide a succinct answer. 1.07. What is the ratio of the Rent(as % of GDP) in Indonesia in 2006 to that in 2007?
Keep it short and to the point. 1.27. What is the ratio of the Rent(as % of GDP) in Norway in 2006 to that in 2007?
Offer a very short reply. 1.15. What is the ratio of the Rent(as % of GDP) in Tanzania in 2006 to that in 2007?
Provide a succinct answer. 1.07. What is the ratio of the Rent(as % of GDP) in Caribbean small states in 2006 to that in 2008?
Give a very brief answer. 0.83. What is the ratio of the Rent(as % of GDP) in Indonesia in 2006 to that in 2008?
Your response must be concise. 0.96. What is the ratio of the Rent(as % of GDP) of Norway in 2006 to that in 2008?
Provide a succinct answer. 0.81. What is the ratio of the Rent(as % of GDP) of Tanzania in 2006 to that in 2008?
Your response must be concise. 0.9. What is the ratio of the Rent(as % of GDP) of Caribbean small states in 2006 to that in 2009?
Keep it short and to the point. 1.56. What is the ratio of the Rent(as % of GDP) in Indonesia in 2006 to that in 2009?
Offer a terse response. 2.82. What is the ratio of the Rent(as % of GDP) of Norway in 2006 to that in 2009?
Your response must be concise. 1.54. What is the ratio of the Rent(as % of GDP) of Tanzania in 2006 to that in 2009?
Your answer should be compact. 1.73. What is the ratio of the Rent(as % of GDP) of Caribbean small states in 2006 to that in 2010?
Your response must be concise. 1.73. What is the ratio of the Rent(as % of GDP) of Indonesia in 2006 to that in 2010?
Keep it short and to the point. 4.14. What is the ratio of the Rent(as % of GDP) of Norway in 2006 to that in 2010?
Your answer should be very brief. 1.83. What is the ratio of the Rent(as % of GDP) of Tanzania in 2006 to that in 2010?
Offer a terse response. 1.69. What is the ratio of the Rent(as % of GDP) in Caribbean small states in 2007 to that in 2008?
Your answer should be compact. 0.78. What is the ratio of the Rent(as % of GDP) of Indonesia in 2007 to that in 2008?
Provide a succinct answer. 0.76. What is the ratio of the Rent(as % of GDP) of Norway in 2007 to that in 2008?
Offer a very short reply. 0.7. What is the ratio of the Rent(as % of GDP) of Tanzania in 2007 to that in 2008?
Ensure brevity in your answer.  0.84. What is the ratio of the Rent(as % of GDP) in Caribbean small states in 2007 to that in 2009?
Give a very brief answer. 1.46. What is the ratio of the Rent(as % of GDP) in Indonesia in 2007 to that in 2009?
Ensure brevity in your answer.  2.23. What is the ratio of the Rent(as % of GDP) of Norway in 2007 to that in 2009?
Your answer should be compact. 1.34. What is the ratio of the Rent(as % of GDP) in Tanzania in 2007 to that in 2009?
Your answer should be compact. 1.61. What is the ratio of the Rent(as % of GDP) of Caribbean small states in 2007 to that in 2010?
Offer a terse response. 1.62. What is the ratio of the Rent(as % of GDP) of Indonesia in 2007 to that in 2010?
Make the answer very short. 3.27. What is the ratio of the Rent(as % of GDP) in Norway in 2007 to that in 2010?
Ensure brevity in your answer.  1.6. What is the ratio of the Rent(as % of GDP) in Tanzania in 2007 to that in 2010?
Your answer should be very brief. 1.57. What is the ratio of the Rent(as % of GDP) of Caribbean small states in 2008 to that in 2009?
Provide a short and direct response. 1.88. What is the ratio of the Rent(as % of GDP) in Indonesia in 2008 to that in 2009?
Your answer should be compact. 2.93. What is the ratio of the Rent(as % of GDP) of Norway in 2008 to that in 2009?
Provide a succinct answer. 1.91. What is the ratio of the Rent(as % of GDP) in Tanzania in 2008 to that in 2009?
Keep it short and to the point. 1.91. What is the ratio of the Rent(as % of GDP) of Caribbean small states in 2008 to that in 2010?
Give a very brief answer. 2.09. What is the ratio of the Rent(as % of GDP) of Indonesia in 2008 to that in 2010?
Provide a short and direct response. 4.3. What is the ratio of the Rent(as % of GDP) of Norway in 2008 to that in 2010?
Offer a terse response. 2.28. What is the ratio of the Rent(as % of GDP) in Tanzania in 2008 to that in 2010?
Provide a short and direct response. 1.87. What is the ratio of the Rent(as % of GDP) of Caribbean small states in 2009 to that in 2010?
Offer a terse response. 1.11. What is the ratio of the Rent(as % of GDP) in Indonesia in 2009 to that in 2010?
Offer a very short reply. 1.47. What is the ratio of the Rent(as % of GDP) in Norway in 2009 to that in 2010?
Keep it short and to the point. 1.19. What is the ratio of the Rent(as % of GDP) of Tanzania in 2009 to that in 2010?
Offer a terse response. 0.98. What is the difference between the highest and the second highest Rent(as % of GDP) in Caribbean small states?
Offer a terse response. 3.45. What is the difference between the highest and the second highest Rent(as % of GDP) of Indonesia?
Your response must be concise. 1.23. What is the difference between the highest and the second highest Rent(as % of GDP) of Norway?
Provide a short and direct response. 0.45. What is the difference between the highest and the second highest Rent(as % of GDP) of Tanzania?
Give a very brief answer. 0.07. What is the difference between the highest and the lowest Rent(as % of GDP) in Caribbean small states?
Give a very brief answer. 10.4. What is the difference between the highest and the lowest Rent(as % of GDP) of Indonesia?
Give a very brief answer. 4.18. What is the difference between the highest and the lowest Rent(as % of GDP) in Norway?
Offer a very short reply. 3.74. What is the difference between the highest and the lowest Rent(as % of GDP) of Tanzania?
Ensure brevity in your answer.  0.55. 